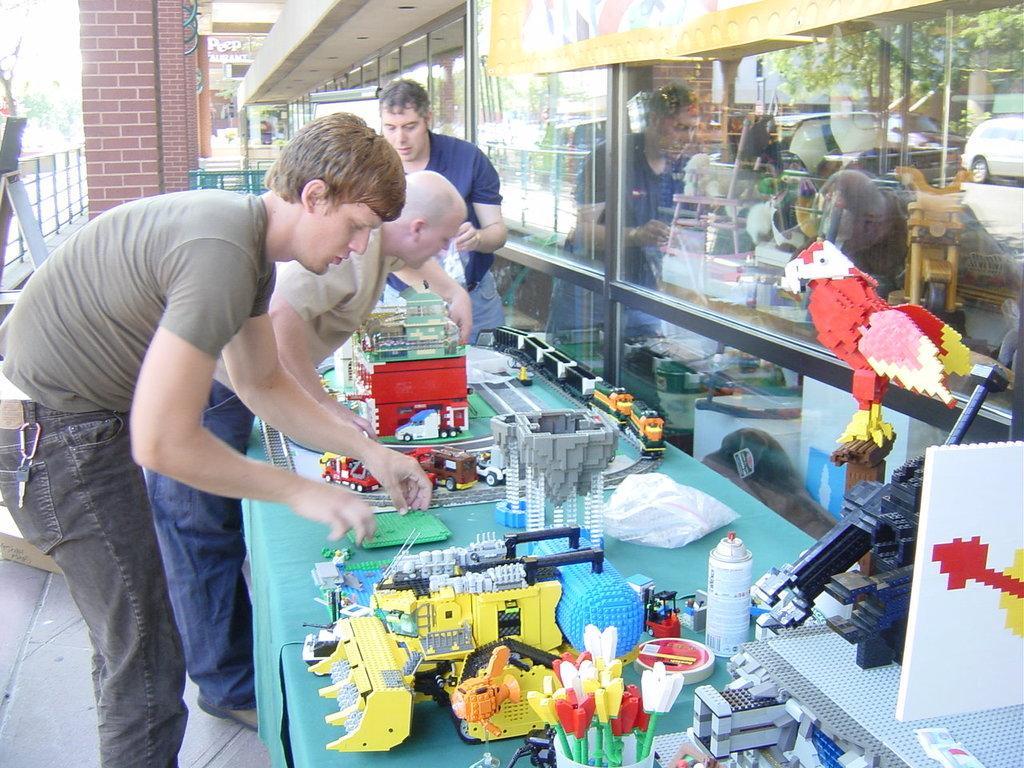Could you give a brief overview of what you see in this image? In this image I can see three people standing and wearing the different color dresses. I can see the table in-front of these people. On the table I can see the miniatures made of lego, bottle and some objects in the cup. To the right I can see the glass. In the background I can see the boards, railing, trees and the sky. 